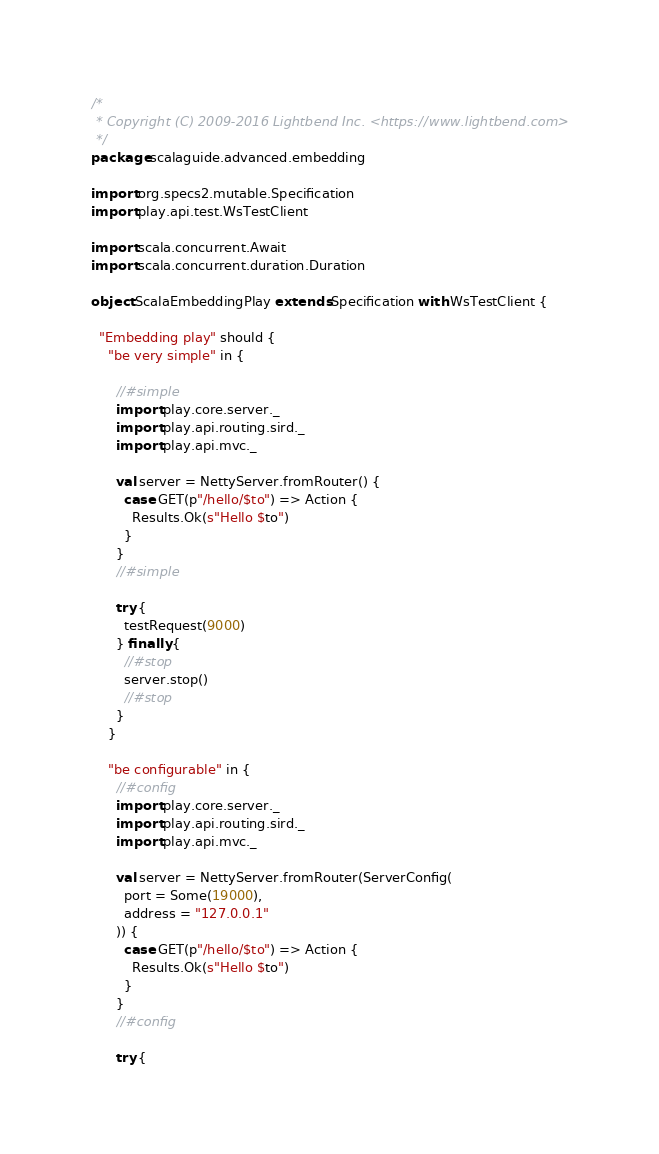Convert code to text. <code><loc_0><loc_0><loc_500><loc_500><_Scala_>/*
 * Copyright (C) 2009-2016 Lightbend Inc. <https://www.lightbend.com>
 */
package scalaguide.advanced.embedding

import org.specs2.mutable.Specification
import play.api.test.WsTestClient

import scala.concurrent.Await
import scala.concurrent.duration.Duration

object ScalaEmbeddingPlay extends Specification with WsTestClient {

  "Embedding play" should {
    "be very simple" in {

      //#simple
      import play.core.server._
      import play.api.routing.sird._
      import play.api.mvc._

      val server = NettyServer.fromRouter() {
        case GET(p"/hello/$to") => Action {
          Results.Ok(s"Hello $to")
        }
      }
      //#simple

      try {
        testRequest(9000)
      } finally {
        //#stop
        server.stop()
        //#stop
      }
    }

    "be configurable" in {
      //#config
      import play.core.server._
      import play.api.routing.sird._
      import play.api.mvc._

      val server = NettyServer.fromRouter(ServerConfig(
        port = Some(19000),
        address = "127.0.0.1"
      )) {
        case GET(p"/hello/$to") => Action {
          Results.Ok(s"Hello $to")
        }
      }
      //#config

      try {</code> 